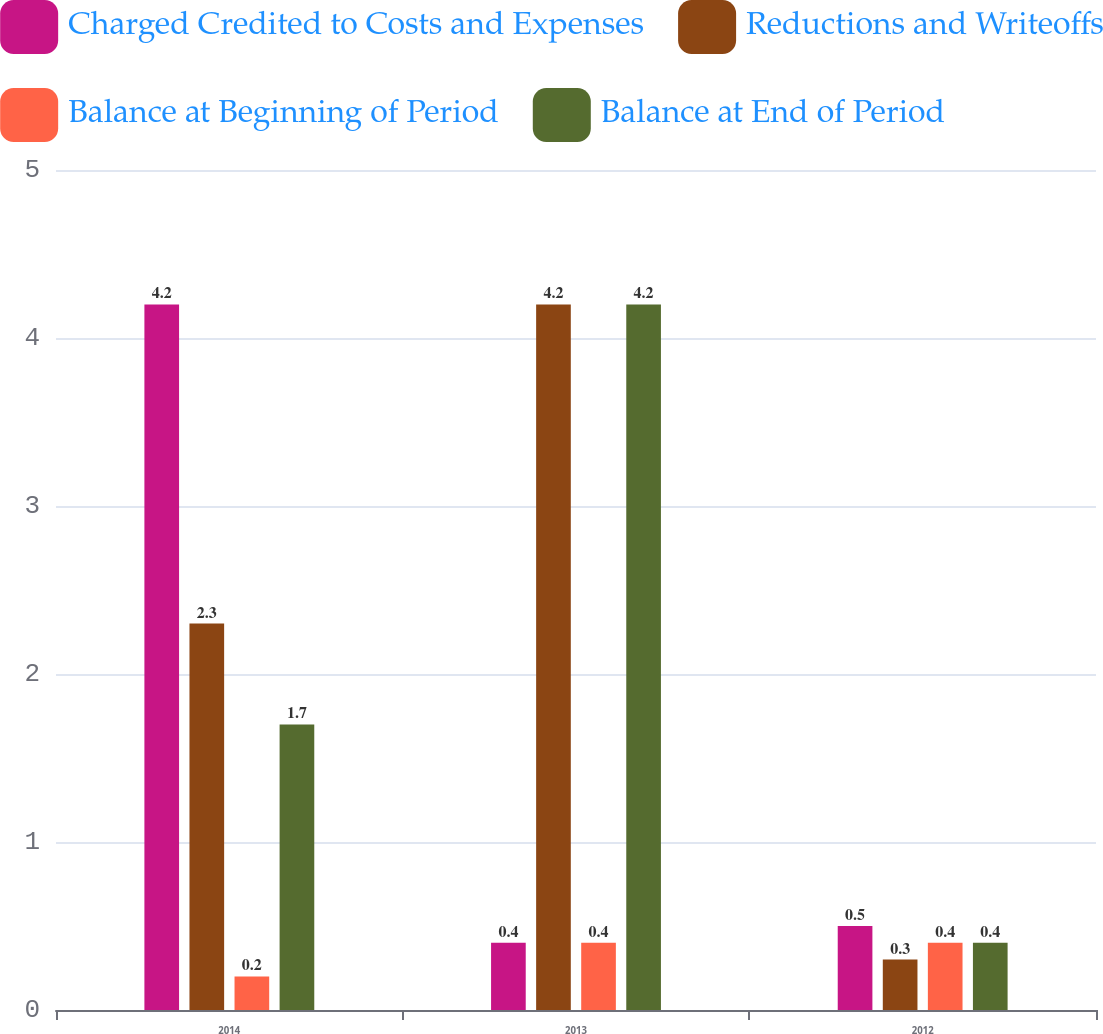Convert chart. <chart><loc_0><loc_0><loc_500><loc_500><stacked_bar_chart><ecel><fcel>2014<fcel>2013<fcel>2012<nl><fcel>Charged Credited to Costs and Expenses<fcel>4.2<fcel>0.4<fcel>0.5<nl><fcel>Reductions and Writeoffs<fcel>2.3<fcel>4.2<fcel>0.3<nl><fcel>Balance at Beginning of Period<fcel>0.2<fcel>0.4<fcel>0.4<nl><fcel>Balance at End of Period<fcel>1.7<fcel>4.2<fcel>0.4<nl></chart> 